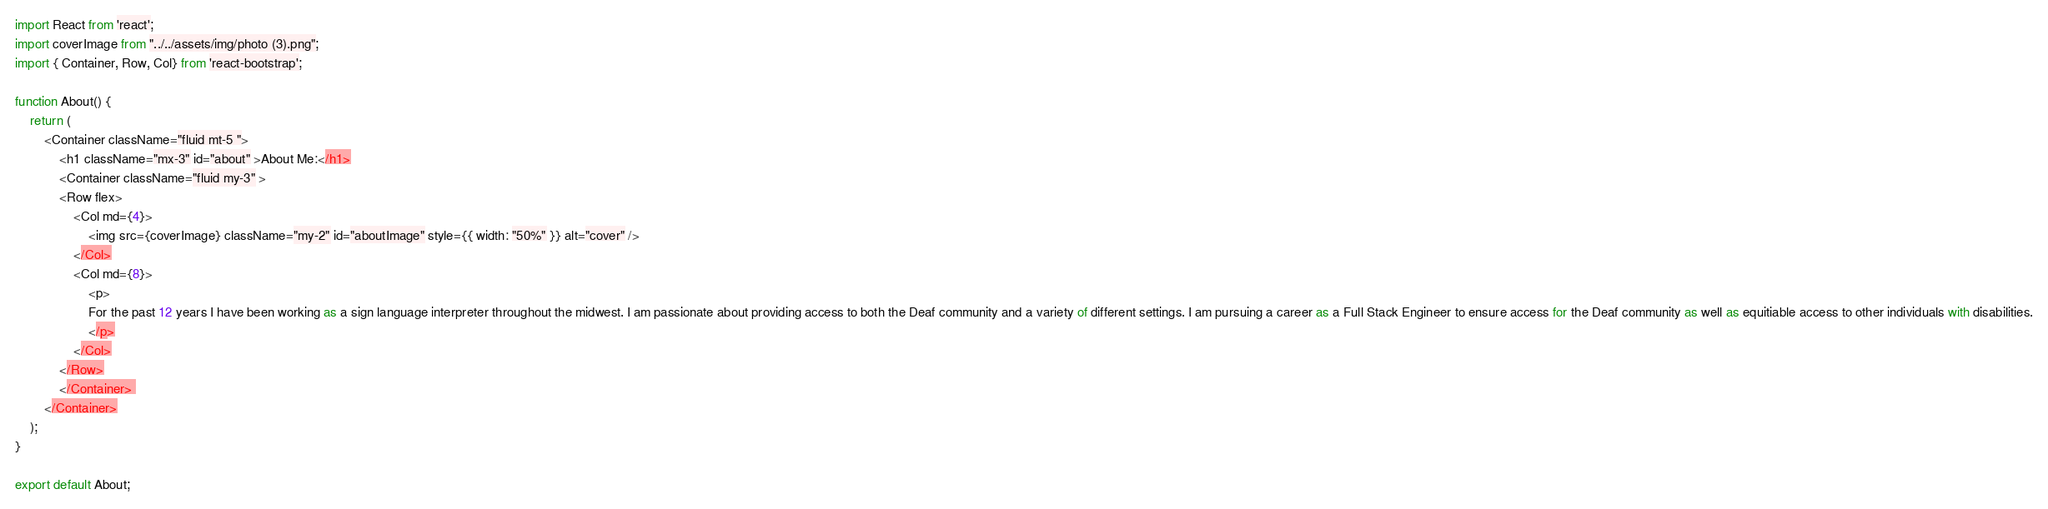<code> <loc_0><loc_0><loc_500><loc_500><_JavaScript_>import React from 'react';
import coverImage from "../../assets/img/photo (3).png";
import { Container, Row, Col} from 'react-bootstrap';

function About() {
    return (
        <Container className="fluid mt-5 ">
            <h1 className="mx-3" id="about" >About Me:</h1>
            <Container className="fluid my-3" >
            <Row flex>
                <Col md={4}>
                    <img src={coverImage} className="my-2" id="aboutImage" style={{ width: "50%" }} alt="cover" />
                </Col>
                <Col md={8}>
                    <p>
                    For the past 12 years I have been working as a sign language interpreter throughout the midwest. I am passionate about providing access to both the Deaf community and a variety of different settings. I am pursuing a career as a Full Stack Engineer to ensure access for the Deaf community as well as equitiable access to other individuals with disabilities.
                    </p>
                </Col>
            </Row>
            </Container> 
        </Container>
    );
}

export default About; </code> 